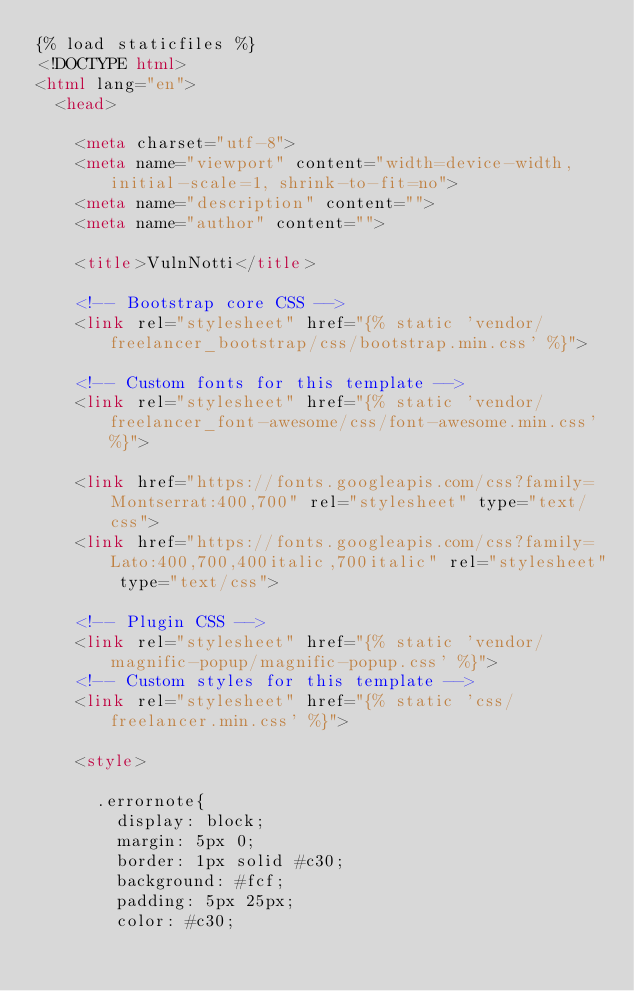Convert code to text. <code><loc_0><loc_0><loc_500><loc_500><_HTML_>{% load staticfiles %}
<!DOCTYPE html>
<html lang="en">
  <head>

    <meta charset="utf-8">
    <meta name="viewport" content="width=device-width, initial-scale=1, shrink-to-fit=no">
    <meta name="description" content="">
    <meta name="author" content="">

    <title>VulnNotti</title>

    <!-- Bootstrap core CSS -->
    <link rel="stylesheet" href="{% static 'vendor/freelancer_bootstrap/css/bootstrap.min.css' %}">

    <!-- Custom fonts for this template -->
    <link rel="stylesheet" href="{% static 'vendor/freelancer_font-awesome/css/font-awesome.min.css' %}">

    <link href="https://fonts.googleapis.com/css?family=Montserrat:400,700" rel="stylesheet" type="text/css">
    <link href="https://fonts.googleapis.com/css?family=Lato:400,700,400italic,700italic" rel="stylesheet" type="text/css">

    <!-- Plugin CSS -->
    <link rel="stylesheet" href="{% static 'vendor/magnific-popup/magnific-popup.css' %}">
    <!-- Custom styles for this template -->
    <link rel="stylesheet" href="{% static 'css/freelancer.min.css' %}">

    <style>

      .errornote{
        display: block;
        margin: 5px 0;
        border: 1px solid #c30;
        background: #fcf;
        padding: 5px 25px;
        color: #c30;</code> 